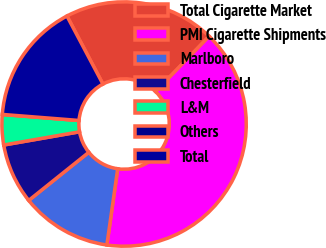<chart> <loc_0><loc_0><loc_500><loc_500><pie_chart><fcel>Total Cigarette Market<fcel>PMI Cigarette Shipments<fcel>Marlboro<fcel>Chesterfield<fcel>L&M<fcel>Others<fcel>Total<nl><fcel>20.0%<fcel>39.99%<fcel>12.0%<fcel>8.0%<fcel>4.0%<fcel>0.0%<fcel>16.0%<nl></chart> 